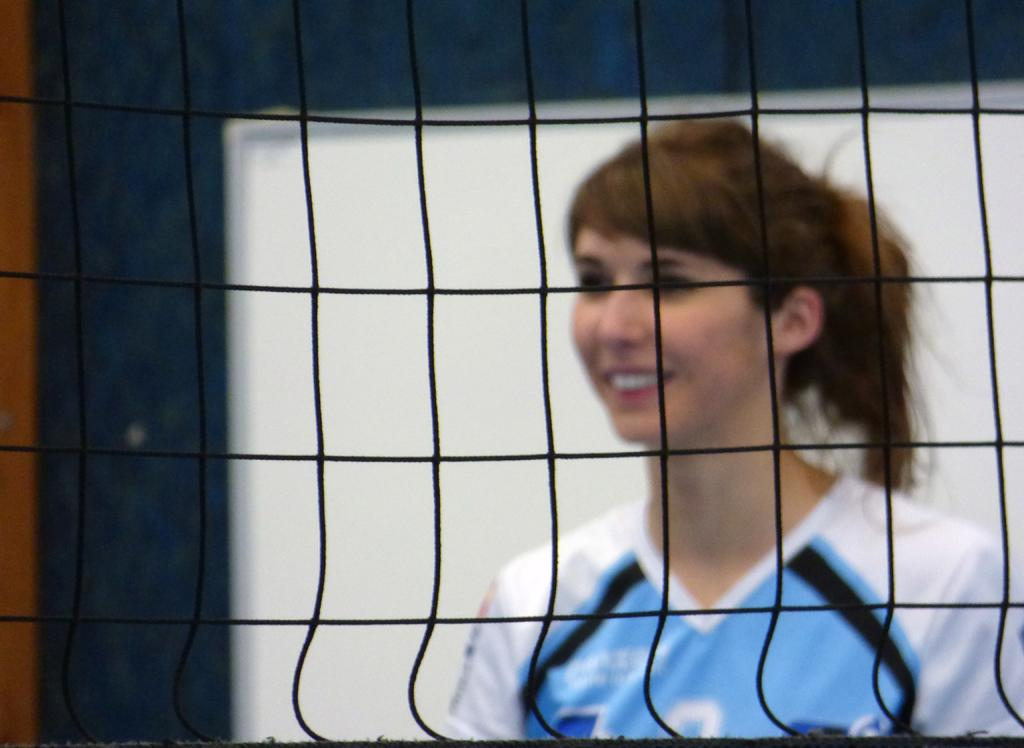What is located in the foreground of the image? There is a net in the foreground of the image. What can be seen in the background of the image? There is a woman and a board in the background of the image. Is there any indication of a wall in the background of the image? It is mentioned that there might be a wall in the background of the image. What type of animal is being approved by the woman in the image? There is no animal present in the image, and the woman is not approving anything. 